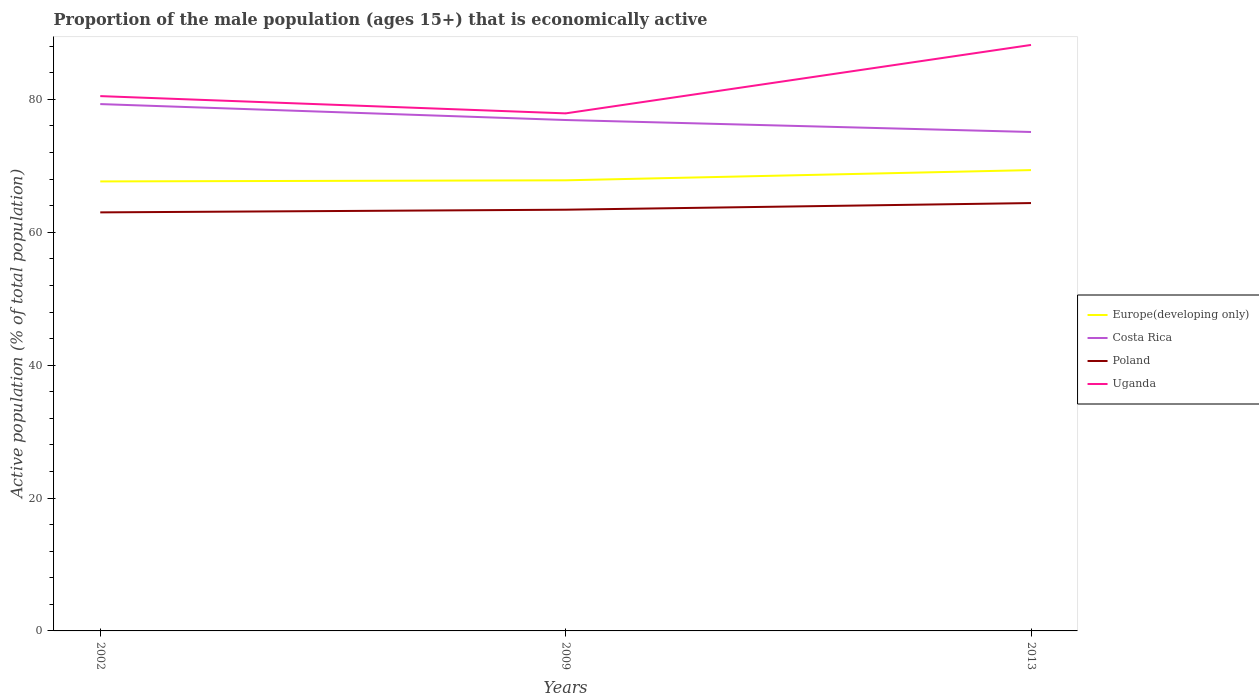How many different coloured lines are there?
Make the answer very short. 4. Does the line corresponding to Poland intersect with the line corresponding to Costa Rica?
Provide a short and direct response. No. Across all years, what is the maximum proportion of the male population that is economically active in Europe(developing only)?
Offer a very short reply. 67.66. In which year was the proportion of the male population that is economically active in Poland maximum?
Offer a very short reply. 2002. What is the total proportion of the male population that is economically active in Uganda in the graph?
Ensure brevity in your answer.  -10.3. What is the difference between the highest and the second highest proportion of the male population that is economically active in Uganda?
Your response must be concise. 10.3. Is the proportion of the male population that is economically active in Europe(developing only) strictly greater than the proportion of the male population that is economically active in Uganda over the years?
Your response must be concise. Yes. How many years are there in the graph?
Provide a succinct answer. 3. What is the difference between two consecutive major ticks on the Y-axis?
Keep it short and to the point. 20. What is the title of the graph?
Your answer should be very brief. Proportion of the male population (ages 15+) that is economically active. What is the label or title of the Y-axis?
Give a very brief answer. Active population (% of total population). What is the Active population (% of total population) of Europe(developing only) in 2002?
Give a very brief answer. 67.66. What is the Active population (% of total population) in Costa Rica in 2002?
Provide a short and direct response. 79.3. What is the Active population (% of total population) of Poland in 2002?
Your answer should be very brief. 63. What is the Active population (% of total population) in Uganda in 2002?
Provide a succinct answer. 80.5. What is the Active population (% of total population) in Europe(developing only) in 2009?
Your answer should be compact. 67.82. What is the Active population (% of total population) of Costa Rica in 2009?
Provide a succinct answer. 76.9. What is the Active population (% of total population) in Poland in 2009?
Your response must be concise. 63.4. What is the Active population (% of total population) in Uganda in 2009?
Make the answer very short. 77.9. What is the Active population (% of total population) of Europe(developing only) in 2013?
Your response must be concise. 69.36. What is the Active population (% of total population) in Costa Rica in 2013?
Your response must be concise. 75.1. What is the Active population (% of total population) of Poland in 2013?
Provide a succinct answer. 64.4. What is the Active population (% of total population) in Uganda in 2013?
Your response must be concise. 88.2. Across all years, what is the maximum Active population (% of total population) in Europe(developing only)?
Keep it short and to the point. 69.36. Across all years, what is the maximum Active population (% of total population) in Costa Rica?
Ensure brevity in your answer.  79.3. Across all years, what is the maximum Active population (% of total population) of Poland?
Give a very brief answer. 64.4. Across all years, what is the maximum Active population (% of total population) in Uganda?
Offer a terse response. 88.2. Across all years, what is the minimum Active population (% of total population) of Europe(developing only)?
Your answer should be compact. 67.66. Across all years, what is the minimum Active population (% of total population) of Costa Rica?
Your answer should be very brief. 75.1. Across all years, what is the minimum Active population (% of total population) in Poland?
Provide a succinct answer. 63. Across all years, what is the minimum Active population (% of total population) in Uganda?
Offer a very short reply. 77.9. What is the total Active population (% of total population) in Europe(developing only) in the graph?
Offer a very short reply. 204.84. What is the total Active population (% of total population) in Costa Rica in the graph?
Provide a succinct answer. 231.3. What is the total Active population (% of total population) in Poland in the graph?
Ensure brevity in your answer.  190.8. What is the total Active population (% of total population) in Uganda in the graph?
Ensure brevity in your answer.  246.6. What is the difference between the Active population (% of total population) in Europe(developing only) in 2002 and that in 2009?
Provide a short and direct response. -0.17. What is the difference between the Active population (% of total population) of Europe(developing only) in 2002 and that in 2013?
Keep it short and to the point. -1.71. What is the difference between the Active population (% of total population) of Europe(developing only) in 2009 and that in 2013?
Give a very brief answer. -1.54. What is the difference between the Active population (% of total population) in Costa Rica in 2009 and that in 2013?
Ensure brevity in your answer.  1.8. What is the difference between the Active population (% of total population) in Poland in 2009 and that in 2013?
Your answer should be compact. -1. What is the difference between the Active population (% of total population) of Europe(developing only) in 2002 and the Active population (% of total population) of Costa Rica in 2009?
Offer a terse response. -9.24. What is the difference between the Active population (% of total population) in Europe(developing only) in 2002 and the Active population (% of total population) in Poland in 2009?
Provide a short and direct response. 4.26. What is the difference between the Active population (% of total population) of Europe(developing only) in 2002 and the Active population (% of total population) of Uganda in 2009?
Offer a very short reply. -10.24. What is the difference between the Active population (% of total population) of Costa Rica in 2002 and the Active population (% of total population) of Uganda in 2009?
Make the answer very short. 1.4. What is the difference between the Active population (% of total population) in Poland in 2002 and the Active population (% of total population) in Uganda in 2009?
Your answer should be very brief. -14.9. What is the difference between the Active population (% of total population) in Europe(developing only) in 2002 and the Active population (% of total population) in Costa Rica in 2013?
Your response must be concise. -7.44. What is the difference between the Active population (% of total population) in Europe(developing only) in 2002 and the Active population (% of total population) in Poland in 2013?
Provide a short and direct response. 3.26. What is the difference between the Active population (% of total population) of Europe(developing only) in 2002 and the Active population (% of total population) of Uganda in 2013?
Your answer should be compact. -20.54. What is the difference between the Active population (% of total population) in Costa Rica in 2002 and the Active population (% of total population) in Uganda in 2013?
Ensure brevity in your answer.  -8.9. What is the difference between the Active population (% of total population) of Poland in 2002 and the Active population (% of total population) of Uganda in 2013?
Provide a succinct answer. -25.2. What is the difference between the Active population (% of total population) in Europe(developing only) in 2009 and the Active population (% of total population) in Costa Rica in 2013?
Your response must be concise. -7.28. What is the difference between the Active population (% of total population) in Europe(developing only) in 2009 and the Active population (% of total population) in Poland in 2013?
Make the answer very short. 3.42. What is the difference between the Active population (% of total population) of Europe(developing only) in 2009 and the Active population (% of total population) of Uganda in 2013?
Offer a terse response. -20.38. What is the difference between the Active population (% of total population) of Costa Rica in 2009 and the Active population (% of total population) of Poland in 2013?
Your answer should be very brief. 12.5. What is the difference between the Active population (% of total population) of Costa Rica in 2009 and the Active population (% of total population) of Uganda in 2013?
Offer a terse response. -11.3. What is the difference between the Active population (% of total population) of Poland in 2009 and the Active population (% of total population) of Uganda in 2013?
Your answer should be very brief. -24.8. What is the average Active population (% of total population) of Europe(developing only) per year?
Ensure brevity in your answer.  68.28. What is the average Active population (% of total population) in Costa Rica per year?
Give a very brief answer. 77.1. What is the average Active population (% of total population) in Poland per year?
Ensure brevity in your answer.  63.6. What is the average Active population (% of total population) in Uganda per year?
Ensure brevity in your answer.  82.2. In the year 2002, what is the difference between the Active population (% of total population) of Europe(developing only) and Active population (% of total population) of Costa Rica?
Keep it short and to the point. -11.64. In the year 2002, what is the difference between the Active population (% of total population) of Europe(developing only) and Active population (% of total population) of Poland?
Provide a succinct answer. 4.66. In the year 2002, what is the difference between the Active population (% of total population) of Europe(developing only) and Active population (% of total population) of Uganda?
Your answer should be compact. -12.84. In the year 2002, what is the difference between the Active population (% of total population) in Poland and Active population (% of total population) in Uganda?
Keep it short and to the point. -17.5. In the year 2009, what is the difference between the Active population (% of total population) in Europe(developing only) and Active population (% of total population) in Costa Rica?
Offer a very short reply. -9.08. In the year 2009, what is the difference between the Active population (% of total population) of Europe(developing only) and Active population (% of total population) of Poland?
Give a very brief answer. 4.42. In the year 2009, what is the difference between the Active population (% of total population) in Europe(developing only) and Active population (% of total population) in Uganda?
Keep it short and to the point. -10.08. In the year 2009, what is the difference between the Active population (% of total population) in Costa Rica and Active population (% of total population) in Uganda?
Your answer should be very brief. -1. In the year 2013, what is the difference between the Active population (% of total population) of Europe(developing only) and Active population (% of total population) of Costa Rica?
Provide a succinct answer. -5.74. In the year 2013, what is the difference between the Active population (% of total population) of Europe(developing only) and Active population (% of total population) of Poland?
Provide a short and direct response. 4.96. In the year 2013, what is the difference between the Active population (% of total population) of Europe(developing only) and Active population (% of total population) of Uganda?
Your answer should be very brief. -18.84. In the year 2013, what is the difference between the Active population (% of total population) of Costa Rica and Active population (% of total population) of Uganda?
Provide a short and direct response. -13.1. In the year 2013, what is the difference between the Active population (% of total population) of Poland and Active population (% of total population) of Uganda?
Provide a succinct answer. -23.8. What is the ratio of the Active population (% of total population) of Europe(developing only) in 2002 to that in 2009?
Your response must be concise. 1. What is the ratio of the Active population (% of total population) of Costa Rica in 2002 to that in 2009?
Offer a very short reply. 1.03. What is the ratio of the Active population (% of total population) in Poland in 2002 to that in 2009?
Give a very brief answer. 0.99. What is the ratio of the Active population (% of total population) in Uganda in 2002 to that in 2009?
Provide a succinct answer. 1.03. What is the ratio of the Active population (% of total population) of Europe(developing only) in 2002 to that in 2013?
Provide a short and direct response. 0.98. What is the ratio of the Active population (% of total population) in Costa Rica in 2002 to that in 2013?
Provide a short and direct response. 1.06. What is the ratio of the Active population (% of total population) of Poland in 2002 to that in 2013?
Provide a succinct answer. 0.98. What is the ratio of the Active population (% of total population) in Uganda in 2002 to that in 2013?
Your response must be concise. 0.91. What is the ratio of the Active population (% of total population) in Europe(developing only) in 2009 to that in 2013?
Make the answer very short. 0.98. What is the ratio of the Active population (% of total population) in Poland in 2009 to that in 2013?
Your response must be concise. 0.98. What is the ratio of the Active population (% of total population) of Uganda in 2009 to that in 2013?
Keep it short and to the point. 0.88. What is the difference between the highest and the second highest Active population (% of total population) of Europe(developing only)?
Your answer should be compact. 1.54. What is the difference between the highest and the second highest Active population (% of total population) of Poland?
Keep it short and to the point. 1. What is the difference between the highest and the second highest Active population (% of total population) of Uganda?
Make the answer very short. 7.7. What is the difference between the highest and the lowest Active population (% of total population) of Europe(developing only)?
Offer a very short reply. 1.71. What is the difference between the highest and the lowest Active population (% of total population) of Poland?
Give a very brief answer. 1.4. 